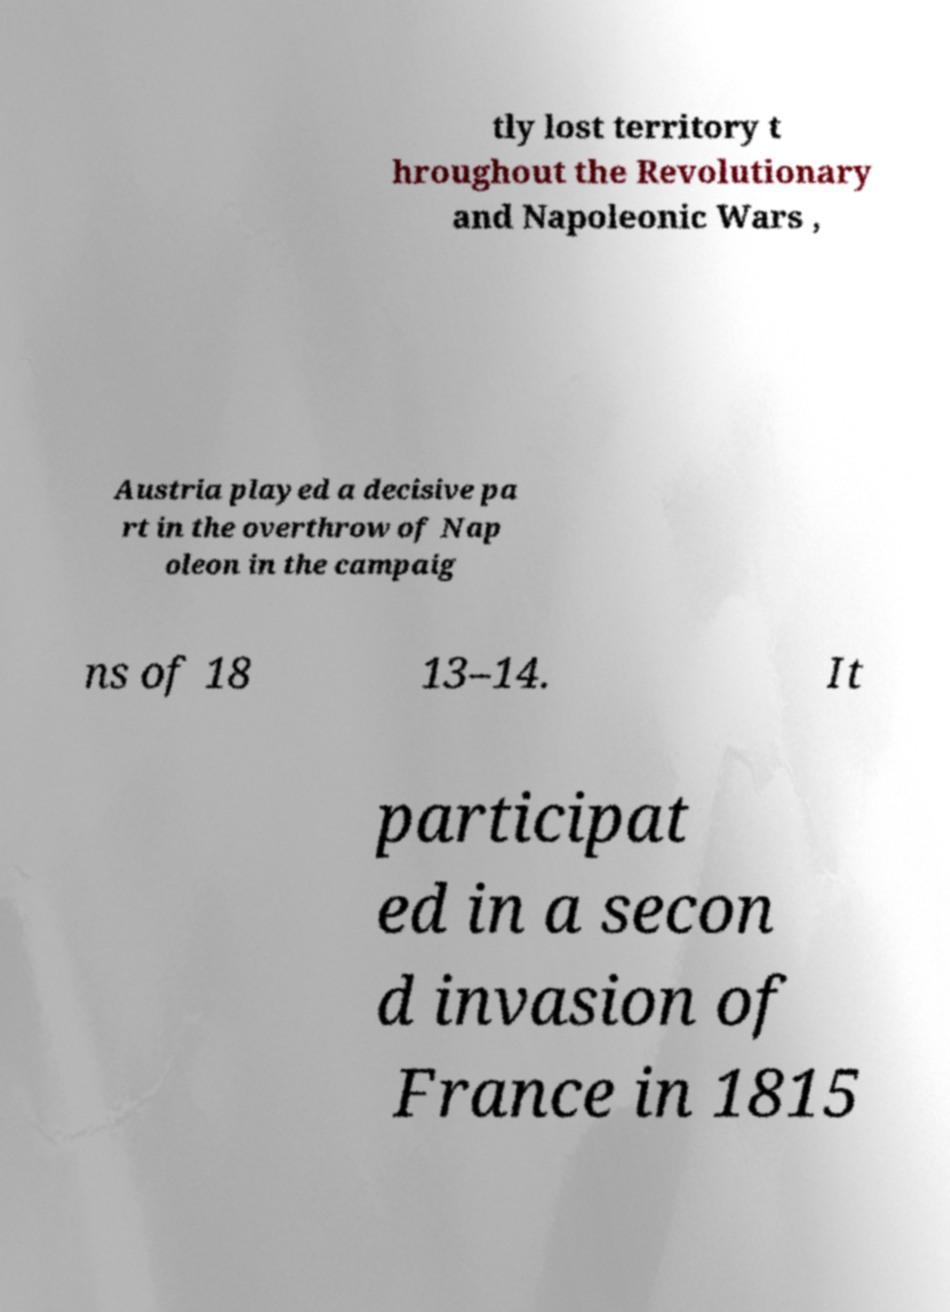Please identify and transcribe the text found in this image. tly lost territory t hroughout the Revolutionary and Napoleonic Wars , Austria played a decisive pa rt in the overthrow of Nap oleon in the campaig ns of 18 13–14. It participat ed in a secon d invasion of France in 1815 